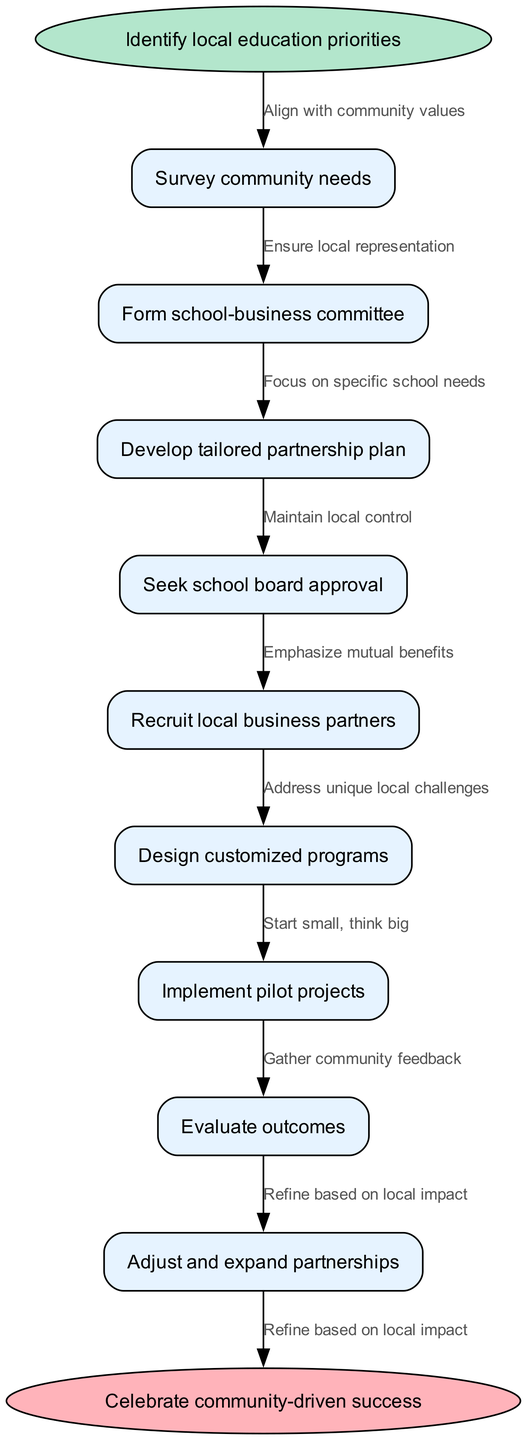What is the first step in the partnership workflow? According to the diagram, the first step is represented by the start node, which states "Identify local education priorities."
Answer: Identify local education priorities How many nodes are in the workflow? The workflow consists of one start node, eight intermediate nodes, and one end node, totaling ten nodes.
Answer: 10 What does the edge from "Survey community needs" point to? The edge labeled "Align with community values" connects the node "Survey community needs" to the next node, which is "Form school-business committee."
Answer: Form school-business committee What is the last node in the workflow? The end of the workflow is marked with the end node stating "Celebrate community-driven success."
Answer: Celebrate community-driven success Which step emphasizes mutual benefits? The specific node in the workflow that emphasizes mutual benefits is "Recruit local business partners."
Answer: Recruit local business partners How does the workflow ensure local representation? The edge "Ensure local representation" connects the node "Form school-business committee," indicating that part of the process is focused on maintaining local representation.
Answer: Form school-business committee What is the relationship between "Implement pilot projects" and "Evaluate outcomes"? The node "Implement pilot projects" is followed by an edge that leads to "Evaluate outcomes," indicating that evaluations occur after pilot projects are implemented.
Answer: Evaluate outcomes What is the focus of the node "Develop tailored partnership plan"? The focus of this node is to address the unique local challenges that are pertinent to the partnership between schools and businesses.
Answer: Address unique local challenges What should be gathered after implementing the pilot projects? The workflow specifies that community feedback should be gathered, which is indicated by the edge "Gather community feedback" after the node for "Implement pilot projects."
Answer: Gather community feedback 